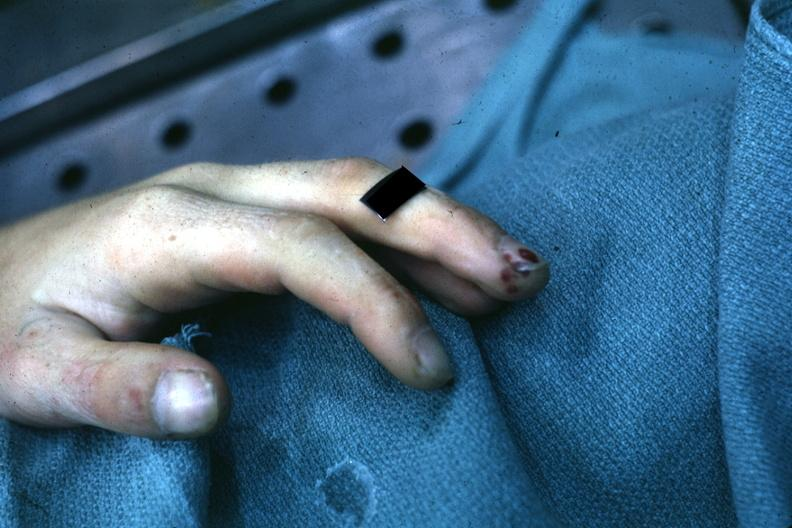s dysplastic present?
Answer the question using a single word or phrase. No 